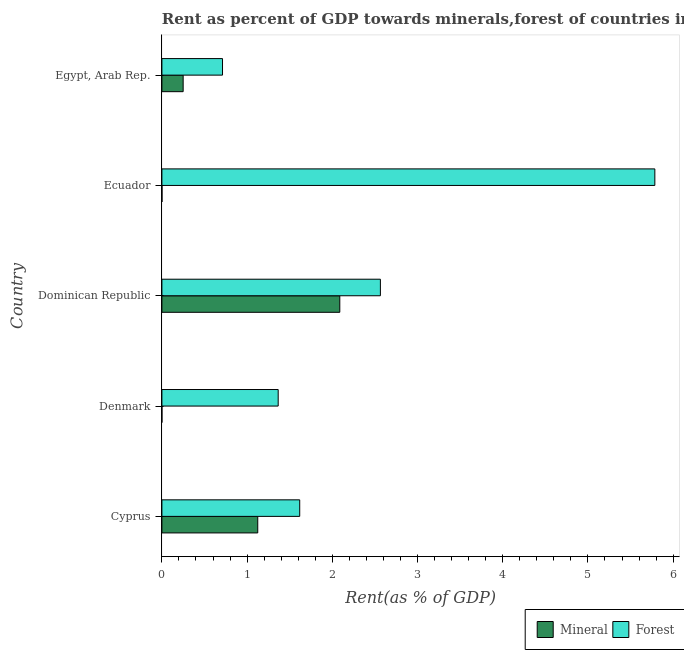How many different coloured bars are there?
Offer a terse response. 2. Are the number of bars per tick equal to the number of legend labels?
Keep it short and to the point. Yes. How many bars are there on the 5th tick from the bottom?
Provide a succinct answer. 2. What is the forest rent in Egypt, Arab Rep.?
Ensure brevity in your answer.  0.71. Across all countries, what is the maximum forest rent?
Make the answer very short. 5.79. Across all countries, what is the minimum mineral rent?
Provide a short and direct response. 5.721432634643411e-5. In which country was the forest rent maximum?
Provide a short and direct response. Ecuador. What is the total mineral rent in the graph?
Ensure brevity in your answer.  3.46. What is the difference between the mineral rent in Denmark and that in Egypt, Arab Rep.?
Provide a succinct answer. -0.25. What is the difference between the forest rent in Cyprus and the mineral rent in Denmark?
Make the answer very short. 1.62. What is the average forest rent per country?
Offer a very short reply. 2.41. What is the difference between the forest rent and mineral rent in Dominican Republic?
Offer a terse response. 0.48. In how many countries, is the mineral rent greater than 5.8 %?
Ensure brevity in your answer.  0. What is the ratio of the forest rent in Ecuador to that in Egypt, Arab Rep.?
Provide a succinct answer. 8.13. What is the difference between the highest and the second highest forest rent?
Ensure brevity in your answer.  3.22. What is the difference between the highest and the lowest forest rent?
Give a very brief answer. 5.07. In how many countries, is the forest rent greater than the average forest rent taken over all countries?
Ensure brevity in your answer.  2. Is the sum of the mineral rent in Denmark and Dominican Republic greater than the maximum forest rent across all countries?
Your answer should be very brief. No. What does the 2nd bar from the top in Denmark represents?
Offer a terse response. Mineral. What does the 1st bar from the bottom in Cyprus represents?
Keep it short and to the point. Mineral. How many bars are there?
Your answer should be compact. 10. Are all the bars in the graph horizontal?
Offer a very short reply. Yes. How many countries are there in the graph?
Your answer should be compact. 5. What is the difference between two consecutive major ticks on the X-axis?
Keep it short and to the point. 1. Are the values on the major ticks of X-axis written in scientific E-notation?
Make the answer very short. No. Does the graph contain any zero values?
Provide a succinct answer. No. Does the graph contain grids?
Your answer should be compact. No. Where does the legend appear in the graph?
Keep it short and to the point. Bottom right. What is the title of the graph?
Offer a terse response. Rent as percent of GDP towards minerals,forest of countries in 1975. Does "Long-term debt" appear as one of the legend labels in the graph?
Your response must be concise. No. What is the label or title of the X-axis?
Ensure brevity in your answer.  Rent(as % of GDP). What is the Rent(as % of GDP) in Mineral in Cyprus?
Your answer should be very brief. 1.12. What is the Rent(as % of GDP) in Forest in Cyprus?
Make the answer very short. 1.62. What is the Rent(as % of GDP) in Mineral in Denmark?
Make the answer very short. 5.721432634643411e-5. What is the Rent(as % of GDP) of Forest in Denmark?
Make the answer very short. 1.36. What is the Rent(as % of GDP) in Mineral in Dominican Republic?
Provide a succinct answer. 2.09. What is the Rent(as % of GDP) of Forest in Dominican Republic?
Offer a very short reply. 2.56. What is the Rent(as % of GDP) in Mineral in Ecuador?
Offer a very short reply. 0. What is the Rent(as % of GDP) of Forest in Ecuador?
Provide a succinct answer. 5.79. What is the Rent(as % of GDP) in Mineral in Egypt, Arab Rep.?
Make the answer very short. 0.25. What is the Rent(as % of GDP) of Forest in Egypt, Arab Rep.?
Your response must be concise. 0.71. Across all countries, what is the maximum Rent(as % of GDP) in Mineral?
Ensure brevity in your answer.  2.09. Across all countries, what is the maximum Rent(as % of GDP) of Forest?
Make the answer very short. 5.79. Across all countries, what is the minimum Rent(as % of GDP) in Mineral?
Make the answer very short. 5.721432634643411e-5. Across all countries, what is the minimum Rent(as % of GDP) of Forest?
Your response must be concise. 0.71. What is the total Rent(as % of GDP) of Mineral in the graph?
Offer a very short reply. 3.46. What is the total Rent(as % of GDP) of Forest in the graph?
Your answer should be very brief. 12.04. What is the difference between the Rent(as % of GDP) of Mineral in Cyprus and that in Denmark?
Your answer should be very brief. 1.12. What is the difference between the Rent(as % of GDP) in Forest in Cyprus and that in Denmark?
Offer a very short reply. 0.25. What is the difference between the Rent(as % of GDP) in Mineral in Cyprus and that in Dominican Republic?
Provide a short and direct response. -0.96. What is the difference between the Rent(as % of GDP) in Forest in Cyprus and that in Dominican Republic?
Your answer should be compact. -0.95. What is the difference between the Rent(as % of GDP) in Mineral in Cyprus and that in Ecuador?
Ensure brevity in your answer.  1.12. What is the difference between the Rent(as % of GDP) in Forest in Cyprus and that in Ecuador?
Keep it short and to the point. -4.17. What is the difference between the Rent(as % of GDP) in Mineral in Cyprus and that in Egypt, Arab Rep.?
Your answer should be very brief. 0.88. What is the difference between the Rent(as % of GDP) of Forest in Cyprus and that in Egypt, Arab Rep.?
Offer a terse response. 0.91. What is the difference between the Rent(as % of GDP) of Mineral in Denmark and that in Dominican Republic?
Offer a terse response. -2.09. What is the difference between the Rent(as % of GDP) in Forest in Denmark and that in Dominican Republic?
Offer a very short reply. -1.2. What is the difference between the Rent(as % of GDP) in Mineral in Denmark and that in Ecuador?
Your answer should be compact. -0. What is the difference between the Rent(as % of GDP) of Forest in Denmark and that in Ecuador?
Your response must be concise. -4.42. What is the difference between the Rent(as % of GDP) of Mineral in Denmark and that in Egypt, Arab Rep.?
Ensure brevity in your answer.  -0.25. What is the difference between the Rent(as % of GDP) of Forest in Denmark and that in Egypt, Arab Rep.?
Keep it short and to the point. 0.65. What is the difference between the Rent(as % of GDP) in Mineral in Dominican Republic and that in Ecuador?
Ensure brevity in your answer.  2.09. What is the difference between the Rent(as % of GDP) of Forest in Dominican Republic and that in Ecuador?
Make the answer very short. -3.22. What is the difference between the Rent(as % of GDP) in Mineral in Dominican Republic and that in Egypt, Arab Rep.?
Offer a terse response. 1.84. What is the difference between the Rent(as % of GDP) in Forest in Dominican Republic and that in Egypt, Arab Rep.?
Provide a short and direct response. 1.85. What is the difference between the Rent(as % of GDP) in Mineral in Ecuador and that in Egypt, Arab Rep.?
Your answer should be compact. -0.25. What is the difference between the Rent(as % of GDP) of Forest in Ecuador and that in Egypt, Arab Rep.?
Offer a very short reply. 5.07. What is the difference between the Rent(as % of GDP) of Mineral in Cyprus and the Rent(as % of GDP) of Forest in Denmark?
Your answer should be compact. -0.24. What is the difference between the Rent(as % of GDP) of Mineral in Cyprus and the Rent(as % of GDP) of Forest in Dominican Republic?
Keep it short and to the point. -1.44. What is the difference between the Rent(as % of GDP) of Mineral in Cyprus and the Rent(as % of GDP) of Forest in Ecuador?
Offer a very short reply. -4.66. What is the difference between the Rent(as % of GDP) in Mineral in Cyprus and the Rent(as % of GDP) in Forest in Egypt, Arab Rep.?
Your response must be concise. 0.41. What is the difference between the Rent(as % of GDP) of Mineral in Denmark and the Rent(as % of GDP) of Forest in Dominican Republic?
Give a very brief answer. -2.56. What is the difference between the Rent(as % of GDP) of Mineral in Denmark and the Rent(as % of GDP) of Forest in Ecuador?
Give a very brief answer. -5.79. What is the difference between the Rent(as % of GDP) of Mineral in Denmark and the Rent(as % of GDP) of Forest in Egypt, Arab Rep.?
Your answer should be very brief. -0.71. What is the difference between the Rent(as % of GDP) of Mineral in Dominican Republic and the Rent(as % of GDP) of Forest in Ecuador?
Provide a short and direct response. -3.7. What is the difference between the Rent(as % of GDP) of Mineral in Dominican Republic and the Rent(as % of GDP) of Forest in Egypt, Arab Rep.?
Your response must be concise. 1.38. What is the difference between the Rent(as % of GDP) in Mineral in Ecuador and the Rent(as % of GDP) in Forest in Egypt, Arab Rep.?
Provide a short and direct response. -0.71. What is the average Rent(as % of GDP) of Mineral per country?
Offer a very short reply. 0.69. What is the average Rent(as % of GDP) of Forest per country?
Provide a short and direct response. 2.41. What is the difference between the Rent(as % of GDP) of Mineral and Rent(as % of GDP) of Forest in Cyprus?
Provide a succinct answer. -0.49. What is the difference between the Rent(as % of GDP) of Mineral and Rent(as % of GDP) of Forest in Denmark?
Your response must be concise. -1.36. What is the difference between the Rent(as % of GDP) of Mineral and Rent(as % of GDP) of Forest in Dominican Republic?
Your answer should be compact. -0.48. What is the difference between the Rent(as % of GDP) in Mineral and Rent(as % of GDP) in Forest in Ecuador?
Make the answer very short. -5.78. What is the difference between the Rent(as % of GDP) of Mineral and Rent(as % of GDP) of Forest in Egypt, Arab Rep.?
Make the answer very short. -0.46. What is the ratio of the Rent(as % of GDP) in Mineral in Cyprus to that in Denmark?
Make the answer very short. 1.97e+04. What is the ratio of the Rent(as % of GDP) in Forest in Cyprus to that in Denmark?
Offer a very short reply. 1.19. What is the ratio of the Rent(as % of GDP) of Mineral in Cyprus to that in Dominican Republic?
Give a very brief answer. 0.54. What is the ratio of the Rent(as % of GDP) of Forest in Cyprus to that in Dominican Republic?
Offer a very short reply. 0.63. What is the ratio of the Rent(as % of GDP) in Mineral in Cyprus to that in Ecuador?
Offer a terse response. 1203.71. What is the ratio of the Rent(as % of GDP) of Forest in Cyprus to that in Ecuador?
Your response must be concise. 0.28. What is the ratio of the Rent(as % of GDP) of Mineral in Cyprus to that in Egypt, Arab Rep.?
Provide a succinct answer. 4.51. What is the ratio of the Rent(as % of GDP) in Forest in Cyprus to that in Egypt, Arab Rep.?
Your response must be concise. 2.27. What is the ratio of the Rent(as % of GDP) of Mineral in Denmark to that in Dominican Republic?
Offer a terse response. 0. What is the ratio of the Rent(as % of GDP) in Forest in Denmark to that in Dominican Republic?
Make the answer very short. 0.53. What is the ratio of the Rent(as % of GDP) in Mineral in Denmark to that in Ecuador?
Provide a short and direct response. 0.06. What is the ratio of the Rent(as % of GDP) of Forest in Denmark to that in Ecuador?
Keep it short and to the point. 0.24. What is the ratio of the Rent(as % of GDP) in Mineral in Denmark to that in Egypt, Arab Rep.?
Your answer should be very brief. 0. What is the ratio of the Rent(as % of GDP) of Forest in Denmark to that in Egypt, Arab Rep.?
Your answer should be compact. 1.92. What is the ratio of the Rent(as % of GDP) of Mineral in Dominican Republic to that in Ecuador?
Provide a short and direct response. 2234.06. What is the ratio of the Rent(as % of GDP) of Forest in Dominican Republic to that in Ecuador?
Keep it short and to the point. 0.44. What is the ratio of the Rent(as % of GDP) in Mineral in Dominican Republic to that in Egypt, Arab Rep.?
Offer a very short reply. 8.37. What is the ratio of the Rent(as % of GDP) in Forest in Dominican Republic to that in Egypt, Arab Rep.?
Provide a succinct answer. 3.6. What is the ratio of the Rent(as % of GDP) of Mineral in Ecuador to that in Egypt, Arab Rep.?
Offer a very short reply. 0. What is the ratio of the Rent(as % of GDP) of Forest in Ecuador to that in Egypt, Arab Rep.?
Offer a very short reply. 8.13. What is the difference between the highest and the second highest Rent(as % of GDP) in Mineral?
Provide a short and direct response. 0.96. What is the difference between the highest and the second highest Rent(as % of GDP) of Forest?
Make the answer very short. 3.22. What is the difference between the highest and the lowest Rent(as % of GDP) in Mineral?
Make the answer very short. 2.09. What is the difference between the highest and the lowest Rent(as % of GDP) of Forest?
Provide a short and direct response. 5.07. 